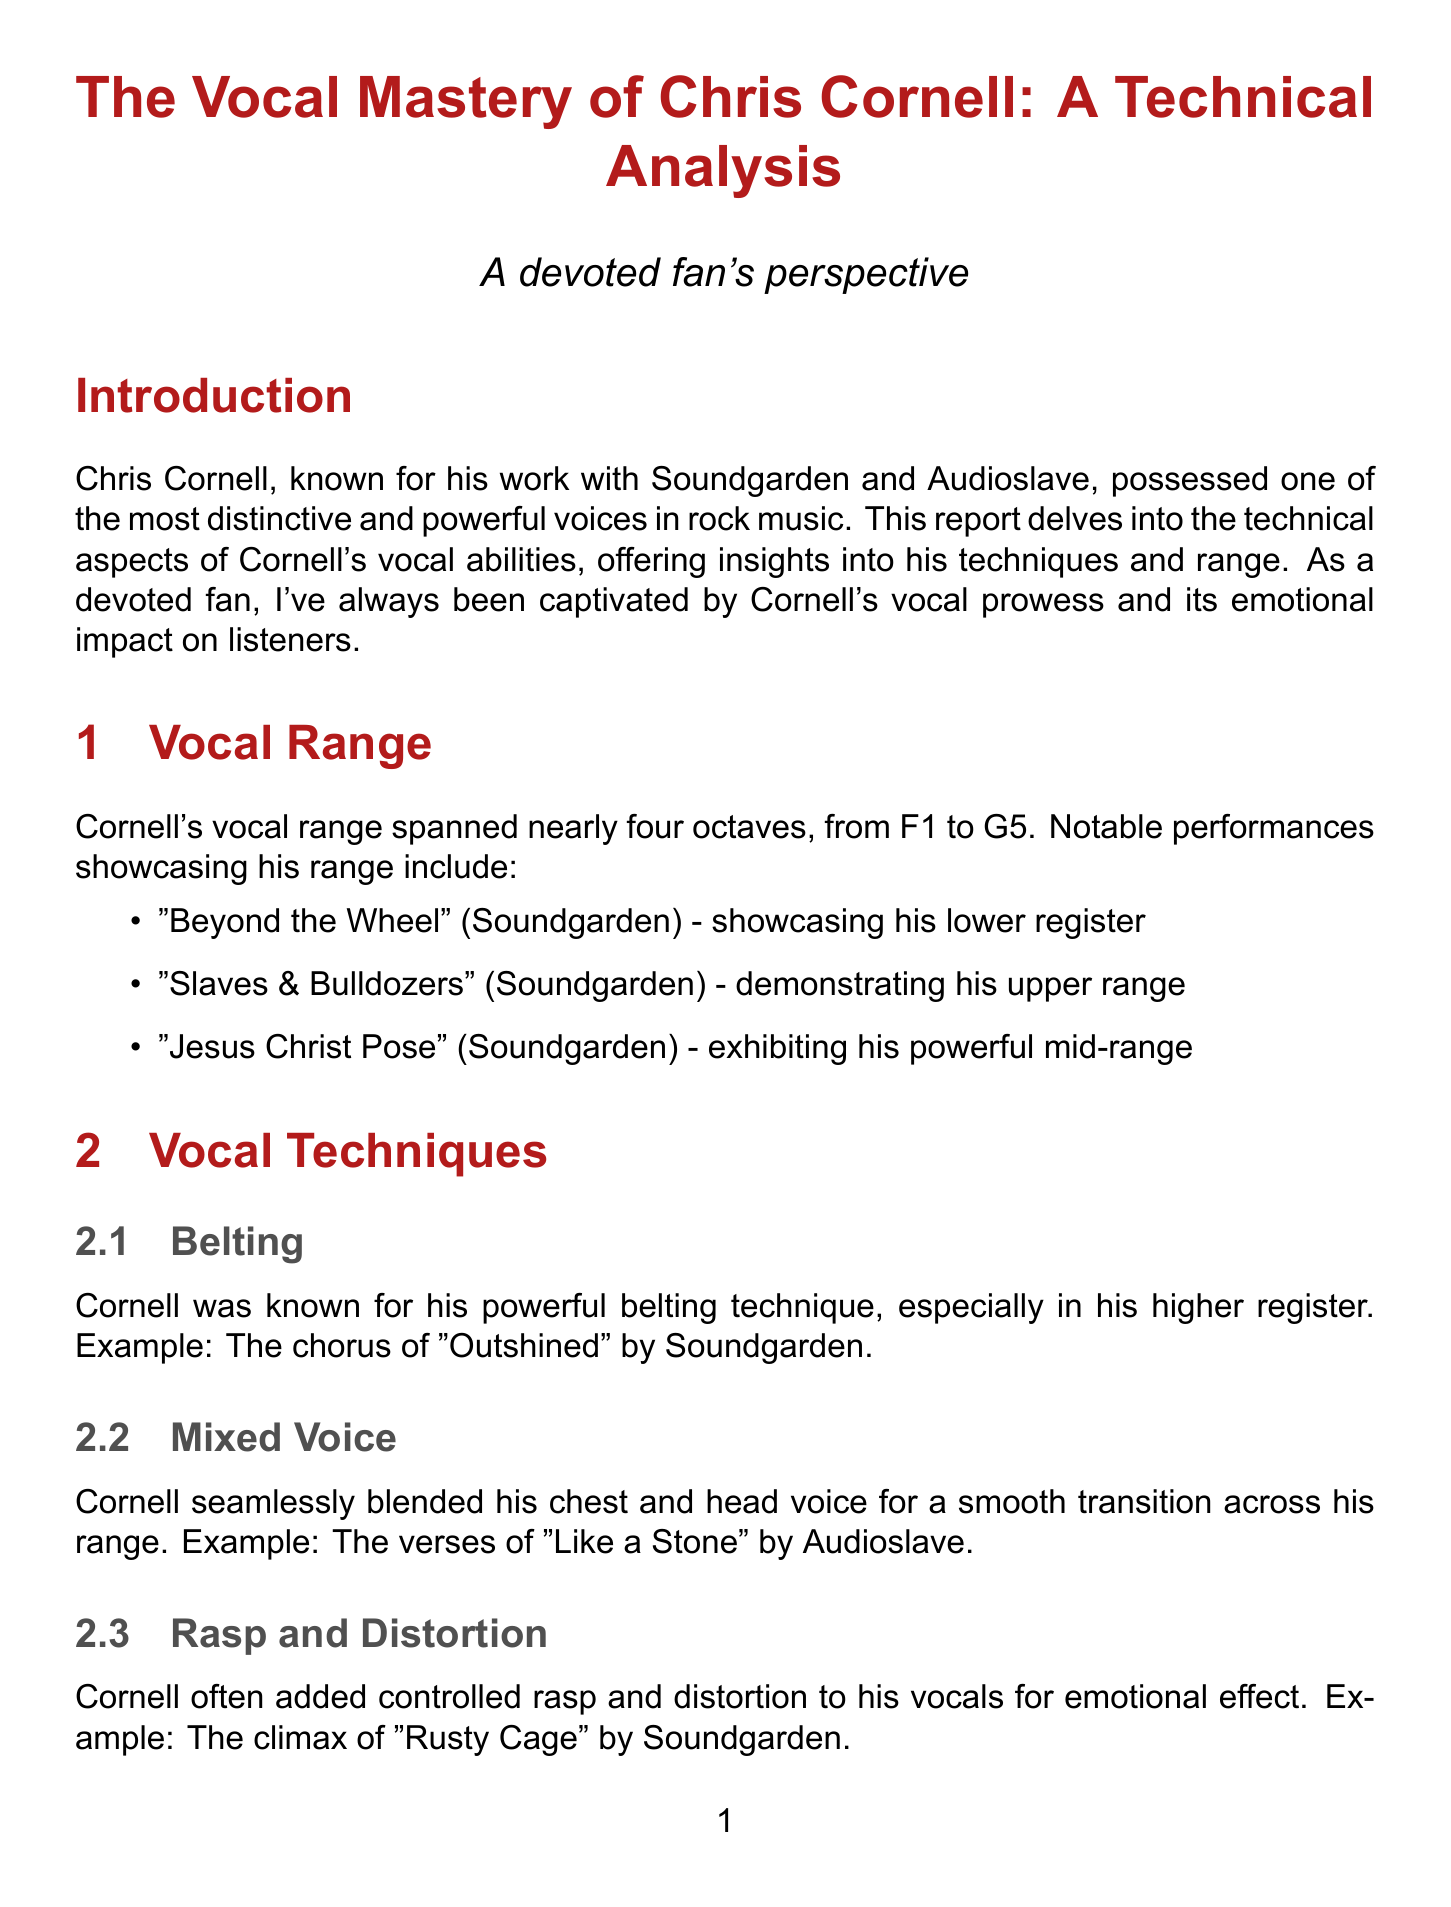What is the title of the report? The title of the report is explicitly stated at the beginning, presenting the subject of the analysis.
Answer: The Vocal Mastery of Chris Cornell: A Technical Analysis What years did Cornell's early Soundgarden career span? The document specifies the years associated with Cornell's early period with Soundgarden, offering insights into his development as a vocalist.
Answer: 1984-1991 Which song showcases Cornell's lower register? The report lists songs that highlight different aspects of Cornell's vocal range, including those that utilize his lower register.
Answer: Beyond the Wheel What technique does Cornell use in the chorus of "Outshined"? The vocal techniques section provides examples of songs where specific techniques are employed, indicating which techniques are highlighted in each song.
Answer: Belting Who provided a quote on Cornell's vocal control? The expert analysis includes quotes from recognized figures in vocal coaching, emphasizing their perspectives on Cornell's abilities.
Answer: Melissa Cross What is the range of Cornell's vocal capabilities? The report encompasses technical details about Cornell's vocal range, mentioning specific pitch levels.
Answer: Nearly four octaves Which vocal technique allows Cornell to access his upper range with ease? The document discusses various vocal techniques, linking them to Cornell's ability to adapt and perform effectively across his range.
Answer: Mixed Voice What is cited as a notable feature in the spectrogram analysis of "Black Hole Sun"? The spectrogram analysis section highlights significant characteristics observed in Cornell's voice during specific songs, pointing to quality aspects of his vocal performance.
Answer: Strong fundamental frequency 